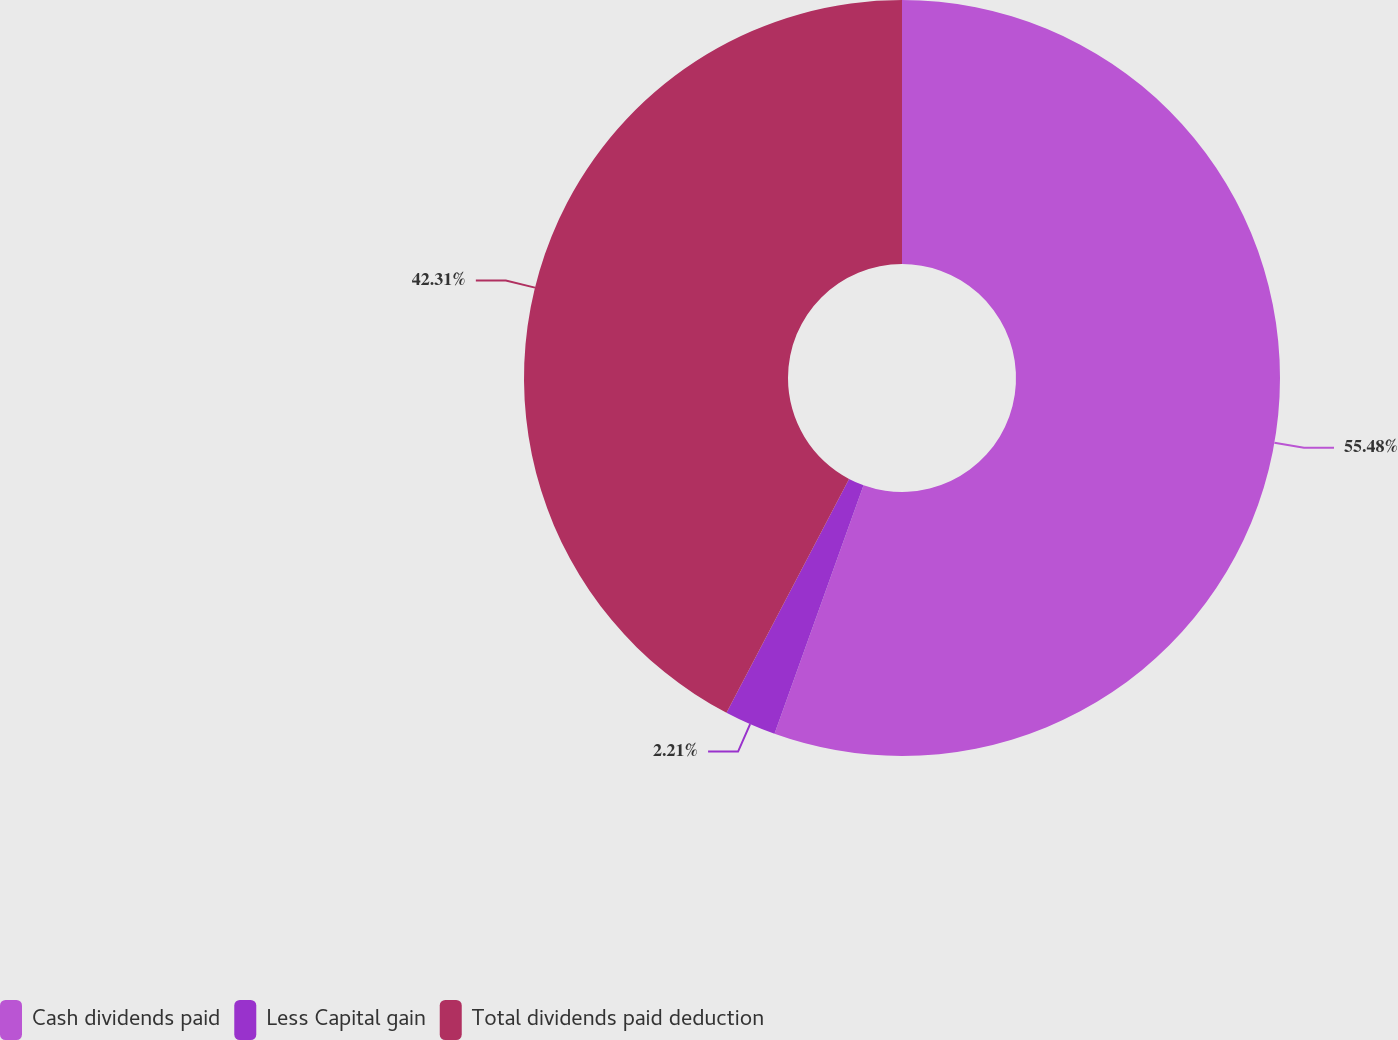Convert chart. <chart><loc_0><loc_0><loc_500><loc_500><pie_chart><fcel>Cash dividends paid<fcel>Less Capital gain<fcel>Total dividends paid deduction<nl><fcel>55.47%<fcel>2.21%<fcel>42.31%<nl></chart> 